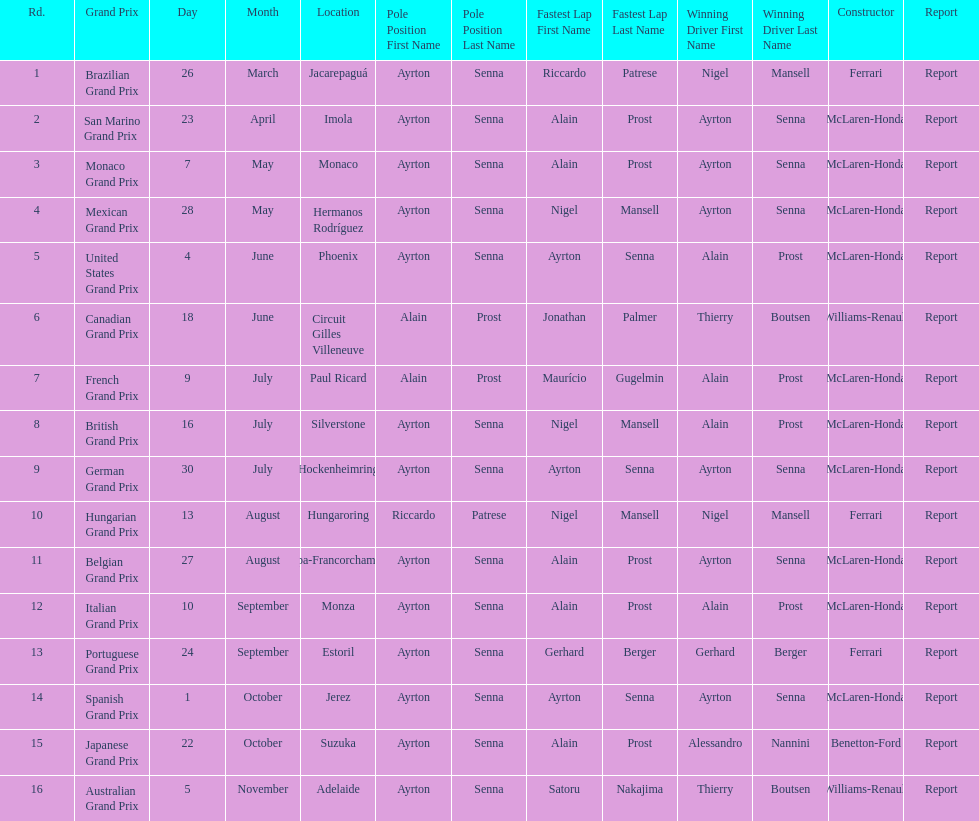How many times was ayrton senna in pole position? 13. 